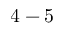Convert formula to latex. <formula><loc_0><loc_0><loc_500><loc_500>4 - 5</formula> 